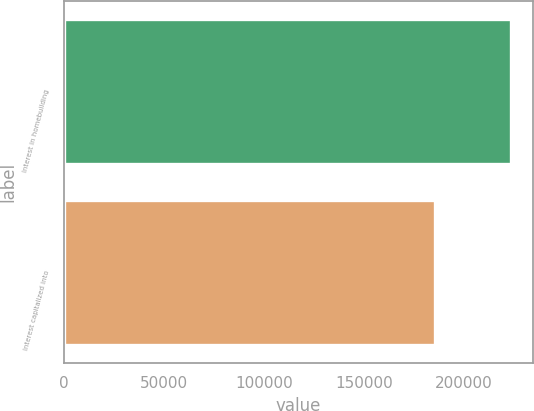<chart> <loc_0><loc_0><loc_500><loc_500><bar_chart><fcel>Interest in homebuilding<fcel>Interest capitalized into<nl><fcel>223591<fcel>185792<nl></chart> 